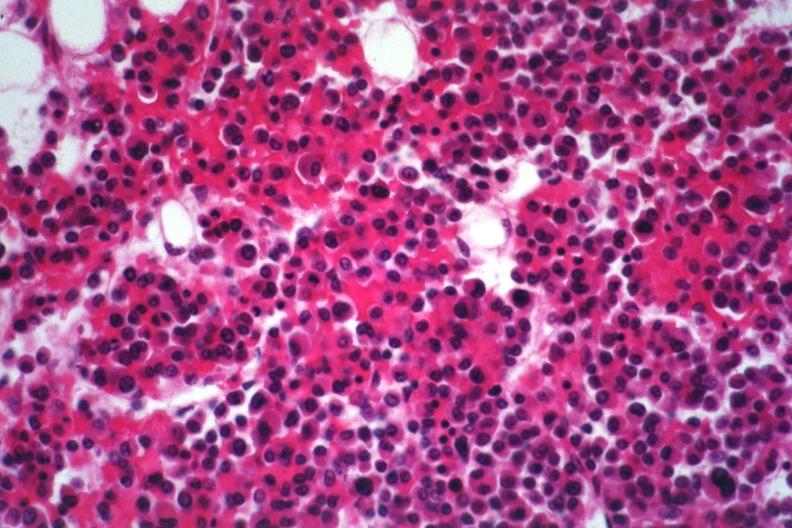what is present?
Answer the question using a single word or phrase. Bone marrow 